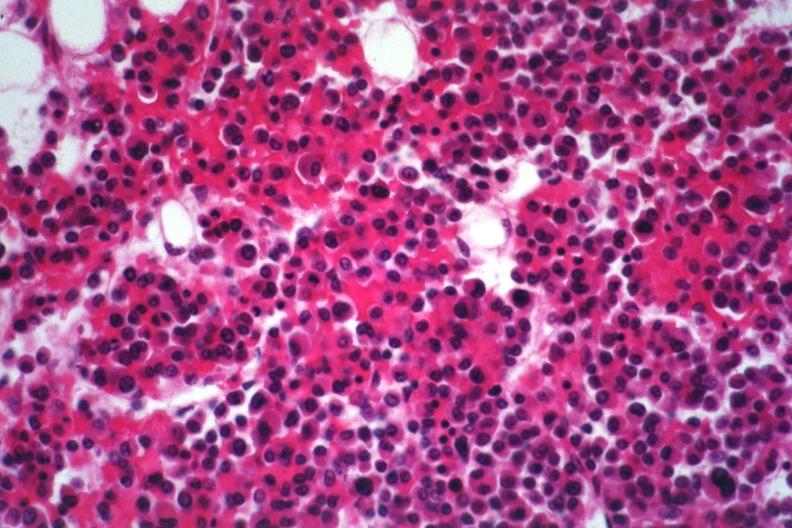what is present?
Answer the question using a single word or phrase. Bone marrow 